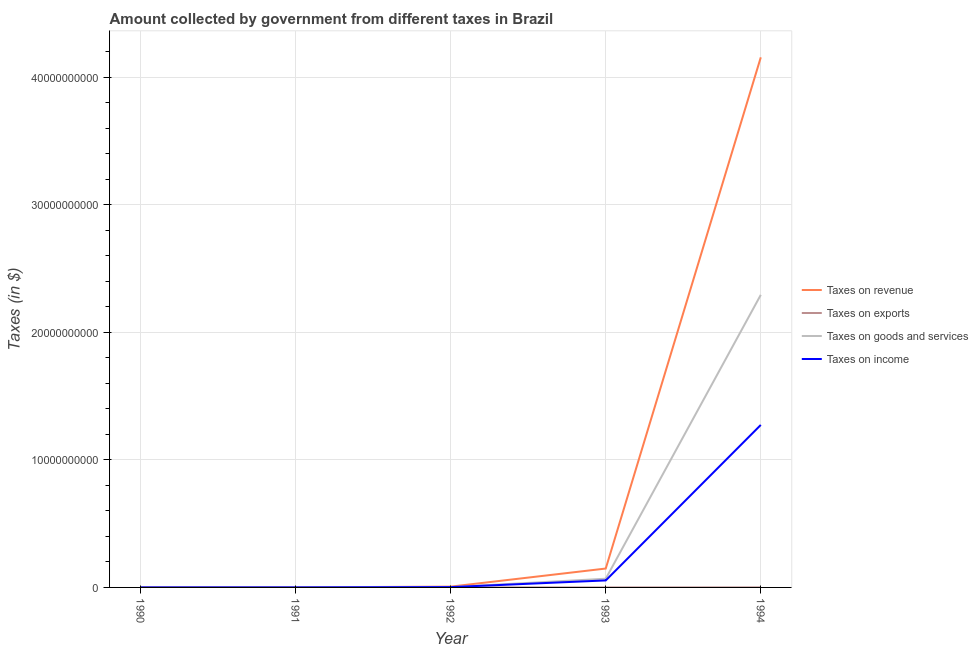How many different coloured lines are there?
Ensure brevity in your answer.  4. Does the line corresponding to amount collected as tax on goods intersect with the line corresponding to amount collected as tax on revenue?
Offer a very short reply. No. Is the number of lines equal to the number of legend labels?
Give a very brief answer. Yes. What is the amount collected as tax on income in 1994?
Provide a short and direct response. 1.27e+1. Across all years, what is the maximum amount collected as tax on goods?
Provide a short and direct response. 2.29e+1. Across all years, what is the minimum amount collected as tax on goods?
Make the answer very short. 6.37e+05. In which year was the amount collected as tax on revenue minimum?
Offer a terse response. 1990. What is the total amount collected as tax on goods in the graph?
Your answer should be compact. 2.36e+1. What is the difference between the amount collected as tax on goods in 1990 and that in 1991?
Provide a short and direct response. -2.03e+06. What is the difference between the amount collected as tax on goods in 1991 and the amount collected as tax on revenue in 1994?
Your answer should be very brief. -4.15e+1. What is the average amount collected as tax on goods per year?
Your answer should be compact. 4.73e+09. In the year 1994, what is the difference between the amount collected as tax on income and amount collected as tax on revenue?
Offer a very short reply. -2.88e+1. In how many years, is the amount collected as tax on income greater than 40000000000 $?
Give a very brief answer. 0. What is the ratio of the amount collected as tax on exports in 1990 to that in 1994?
Offer a very short reply. 0. Is the amount collected as tax on goods in 1990 less than that in 1991?
Give a very brief answer. Yes. Is the difference between the amount collected as tax on revenue in 1992 and 1994 greater than the difference between the amount collected as tax on exports in 1992 and 1994?
Provide a succinct answer. No. What is the difference between the highest and the second highest amount collected as tax on income?
Make the answer very short. 1.22e+1. What is the difference between the highest and the lowest amount collected as tax on revenue?
Offer a very short reply. 4.15e+1. In how many years, is the amount collected as tax on income greater than the average amount collected as tax on income taken over all years?
Ensure brevity in your answer.  1. Is the sum of the amount collected as tax on exports in 1992 and 1994 greater than the maximum amount collected as tax on revenue across all years?
Keep it short and to the point. No. Is it the case that in every year, the sum of the amount collected as tax on income and amount collected as tax on revenue is greater than the sum of amount collected as tax on goods and amount collected as tax on exports?
Provide a succinct answer. No. Does the amount collected as tax on goods monotonically increase over the years?
Offer a terse response. Yes. Is the amount collected as tax on exports strictly greater than the amount collected as tax on income over the years?
Your response must be concise. No. How many years are there in the graph?
Offer a terse response. 5. Are the values on the major ticks of Y-axis written in scientific E-notation?
Give a very brief answer. No. Does the graph contain grids?
Offer a terse response. Yes. What is the title of the graph?
Offer a terse response. Amount collected by government from different taxes in Brazil. Does "Permission" appear as one of the legend labels in the graph?
Offer a terse response. No. What is the label or title of the Y-axis?
Ensure brevity in your answer.  Taxes (in $). What is the Taxes (in $) of Taxes on revenue in 1990?
Give a very brief answer. 1.39e+06. What is the Taxes (in $) in Taxes on exports in 1990?
Provide a succinct answer. 1018.18. What is the Taxes (in $) in Taxes on goods and services in 1990?
Offer a very short reply. 6.37e+05. What is the Taxes (in $) in Taxes on income in 1990?
Make the answer very short. 5.39e+05. What is the Taxes (in $) of Taxes on revenue in 1991?
Offer a terse response. 5.75e+06. What is the Taxes (in $) in Taxes on exports in 1991?
Offer a terse response. 1527.27. What is the Taxes (in $) of Taxes on goods and services in 1991?
Your answer should be compact. 2.67e+06. What is the Taxes (in $) in Taxes on income in 1991?
Ensure brevity in your answer.  2.15e+06. What is the Taxes (in $) of Taxes on revenue in 1992?
Your response must be concise. 6.24e+07. What is the Taxes (in $) of Taxes on exports in 1992?
Keep it short and to the point. 1200. What is the Taxes (in $) in Taxes on goods and services in 1992?
Provide a succinct answer. 2.66e+07. What is the Taxes (in $) of Taxes on income in 1992?
Your answer should be very brief. 2.49e+07. What is the Taxes (in $) of Taxes on revenue in 1993?
Your response must be concise. 1.48e+09. What is the Taxes (in $) in Taxes on goods and services in 1993?
Keep it short and to the point. 6.82e+08. What is the Taxes (in $) of Taxes on income in 1993?
Offer a very short reply. 5.48e+08. What is the Taxes (in $) of Taxes on revenue in 1994?
Provide a short and direct response. 4.15e+1. What is the Taxes (in $) of Taxes on exports in 1994?
Your answer should be very brief. 2.90e+06. What is the Taxes (in $) in Taxes on goods and services in 1994?
Keep it short and to the point. 2.29e+1. What is the Taxes (in $) of Taxes on income in 1994?
Your response must be concise. 1.27e+1. Across all years, what is the maximum Taxes (in $) of Taxes on revenue?
Your answer should be very brief. 4.15e+1. Across all years, what is the maximum Taxes (in $) in Taxes on exports?
Your response must be concise. 2.90e+06. Across all years, what is the maximum Taxes (in $) of Taxes on goods and services?
Keep it short and to the point. 2.29e+1. Across all years, what is the maximum Taxes (in $) of Taxes on income?
Your answer should be compact. 1.27e+1. Across all years, what is the minimum Taxes (in $) of Taxes on revenue?
Offer a terse response. 1.39e+06. Across all years, what is the minimum Taxes (in $) of Taxes on exports?
Keep it short and to the point. 1018.18. Across all years, what is the minimum Taxes (in $) in Taxes on goods and services?
Offer a very short reply. 6.37e+05. Across all years, what is the minimum Taxes (in $) in Taxes on income?
Make the answer very short. 5.39e+05. What is the total Taxes (in $) of Taxes on revenue in the graph?
Offer a very short reply. 4.31e+1. What is the total Taxes (in $) of Taxes on exports in the graph?
Your response must be concise. 3.30e+06. What is the total Taxes (in $) in Taxes on goods and services in the graph?
Offer a very short reply. 2.36e+1. What is the total Taxes (in $) of Taxes on income in the graph?
Ensure brevity in your answer.  1.33e+1. What is the difference between the Taxes (in $) of Taxes on revenue in 1990 and that in 1991?
Give a very brief answer. -4.36e+06. What is the difference between the Taxes (in $) in Taxes on exports in 1990 and that in 1991?
Ensure brevity in your answer.  -509.09. What is the difference between the Taxes (in $) in Taxes on goods and services in 1990 and that in 1991?
Make the answer very short. -2.03e+06. What is the difference between the Taxes (in $) of Taxes on income in 1990 and that in 1991?
Provide a succinct answer. -1.61e+06. What is the difference between the Taxes (in $) in Taxes on revenue in 1990 and that in 1992?
Ensure brevity in your answer.  -6.10e+07. What is the difference between the Taxes (in $) of Taxes on exports in 1990 and that in 1992?
Ensure brevity in your answer.  -181.82. What is the difference between the Taxes (in $) in Taxes on goods and services in 1990 and that in 1992?
Your answer should be compact. -2.59e+07. What is the difference between the Taxes (in $) in Taxes on income in 1990 and that in 1992?
Keep it short and to the point. -2.44e+07. What is the difference between the Taxes (in $) in Taxes on revenue in 1990 and that in 1993?
Keep it short and to the point. -1.48e+09. What is the difference between the Taxes (in $) of Taxes on exports in 1990 and that in 1993?
Offer a terse response. -3.99e+05. What is the difference between the Taxes (in $) in Taxes on goods and services in 1990 and that in 1993?
Keep it short and to the point. -6.82e+08. What is the difference between the Taxes (in $) of Taxes on income in 1990 and that in 1993?
Make the answer very short. -5.48e+08. What is the difference between the Taxes (in $) in Taxes on revenue in 1990 and that in 1994?
Your answer should be compact. -4.15e+1. What is the difference between the Taxes (in $) in Taxes on exports in 1990 and that in 1994?
Make the answer very short. -2.90e+06. What is the difference between the Taxes (in $) of Taxes on goods and services in 1990 and that in 1994?
Make the answer very short. -2.29e+1. What is the difference between the Taxes (in $) in Taxes on income in 1990 and that in 1994?
Provide a short and direct response. -1.27e+1. What is the difference between the Taxes (in $) in Taxes on revenue in 1991 and that in 1992?
Make the answer very short. -5.66e+07. What is the difference between the Taxes (in $) in Taxes on exports in 1991 and that in 1992?
Make the answer very short. 327.27. What is the difference between the Taxes (in $) of Taxes on goods and services in 1991 and that in 1992?
Keep it short and to the point. -2.39e+07. What is the difference between the Taxes (in $) of Taxes on income in 1991 and that in 1992?
Offer a terse response. -2.28e+07. What is the difference between the Taxes (in $) in Taxes on revenue in 1991 and that in 1993?
Your answer should be compact. -1.47e+09. What is the difference between the Taxes (in $) in Taxes on exports in 1991 and that in 1993?
Keep it short and to the point. -3.98e+05. What is the difference between the Taxes (in $) of Taxes on goods and services in 1991 and that in 1993?
Make the answer very short. -6.80e+08. What is the difference between the Taxes (in $) of Taxes on income in 1991 and that in 1993?
Make the answer very short. -5.46e+08. What is the difference between the Taxes (in $) in Taxes on revenue in 1991 and that in 1994?
Ensure brevity in your answer.  -4.15e+1. What is the difference between the Taxes (in $) in Taxes on exports in 1991 and that in 1994?
Give a very brief answer. -2.90e+06. What is the difference between the Taxes (in $) in Taxes on goods and services in 1991 and that in 1994?
Provide a short and direct response. -2.29e+1. What is the difference between the Taxes (in $) of Taxes on income in 1991 and that in 1994?
Provide a succinct answer. -1.27e+1. What is the difference between the Taxes (in $) of Taxes on revenue in 1992 and that in 1993?
Your answer should be very brief. -1.42e+09. What is the difference between the Taxes (in $) in Taxes on exports in 1992 and that in 1993?
Offer a terse response. -3.99e+05. What is the difference between the Taxes (in $) of Taxes on goods and services in 1992 and that in 1993?
Offer a terse response. -6.56e+08. What is the difference between the Taxes (in $) in Taxes on income in 1992 and that in 1993?
Provide a succinct answer. -5.24e+08. What is the difference between the Taxes (in $) in Taxes on revenue in 1992 and that in 1994?
Your answer should be compact. -4.15e+1. What is the difference between the Taxes (in $) of Taxes on exports in 1992 and that in 1994?
Make the answer very short. -2.90e+06. What is the difference between the Taxes (in $) in Taxes on goods and services in 1992 and that in 1994?
Your response must be concise. -2.29e+1. What is the difference between the Taxes (in $) in Taxes on income in 1992 and that in 1994?
Your response must be concise. -1.27e+1. What is the difference between the Taxes (in $) of Taxes on revenue in 1993 and that in 1994?
Offer a terse response. -4.01e+1. What is the difference between the Taxes (in $) of Taxes on exports in 1993 and that in 1994?
Make the answer very short. -2.50e+06. What is the difference between the Taxes (in $) of Taxes on goods and services in 1993 and that in 1994?
Your response must be concise. -2.22e+1. What is the difference between the Taxes (in $) of Taxes on income in 1993 and that in 1994?
Provide a short and direct response. -1.22e+1. What is the difference between the Taxes (in $) in Taxes on revenue in 1990 and the Taxes (in $) in Taxes on exports in 1991?
Provide a succinct answer. 1.39e+06. What is the difference between the Taxes (in $) of Taxes on revenue in 1990 and the Taxes (in $) of Taxes on goods and services in 1991?
Offer a terse response. -1.28e+06. What is the difference between the Taxes (in $) of Taxes on revenue in 1990 and the Taxes (in $) of Taxes on income in 1991?
Offer a terse response. -7.63e+05. What is the difference between the Taxes (in $) of Taxes on exports in 1990 and the Taxes (in $) of Taxes on goods and services in 1991?
Ensure brevity in your answer.  -2.67e+06. What is the difference between the Taxes (in $) of Taxes on exports in 1990 and the Taxes (in $) of Taxes on income in 1991?
Your answer should be very brief. -2.15e+06. What is the difference between the Taxes (in $) in Taxes on goods and services in 1990 and the Taxes (in $) in Taxes on income in 1991?
Your answer should be compact. -1.51e+06. What is the difference between the Taxes (in $) of Taxes on revenue in 1990 and the Taxes (in $) of Taxes on exports in 1992?
Keep it short and to the point. 1.39e+06. What is the difference between the Taxes (in $) in Taxes on revenue in 1990 and the Taxes (in $) in Taxes on goods and services in 1992?
Offer a terse response. -2.52e+07. What is the difference between the Taxes (in $) in Taxes on revenue in 1990 and the Taxes (in $) in Taxes on income in 1992?
Your answer should be very brief. -2.35e+07. What is the difference between the Taxes (in $) in Taxes on exports in 1990 and the Taxes (in $) in Taxes on goods and services in 1992?
Ensure brevity in your answer.  -2.66e+07. What is the difference between the Taxes (in $) in Taxes on exports in 1990 and the Taxes (in $) in Taxes on income in 1992?
Offer a very short reply. -2.49e+07. What is the difference between the Taxes (in $) in Taxes on goods and services in 1990 and the Taxes (in $) in Taxes on income in 1992?
Make the answer very short. -2.43e+07. What is the difference between the Taxes (in $) of Taxes on revenue in 1990 and the Taxes (in $) of Taxes on exports in 1993?
Your response must be concise. 9.87e+05. What is the difference between the Taxes (in $) in Taxes on revenue in 1990 and the Taxes (in $) in Taxes on goods and services in 1993?
Provide a short and direct response. -6.81e+08. What is the difference between the Taxes (in $) of Taxes on revenue in 1990 and the Taxes (in $) of Taxes on income in 1993?
Provide a succinct answer. -5.47e+08. What is the difference between the Taxes (in $) in Taxes on exports in 1990 and the Taxes (in $) in Taxes on goods and services in 1993?
Your answer should be very brief. -6.82e+08. What is the difference between the Taxes (in $) of Taxes on exports in 1990 and the Taxes (in $) of Taxes on income in 1993?
Make the answer very short. -5.48e+08. What is the difference between the Taxes (in $) in Taxes on goods and services in 1990 and the Taxes (in $) in Taxes on income in 1993?
Offer a very short reply. -5.48e+08. What is the difference between the Taxes (in $) in Taxes on revenue in 1990 and the Taxes (in $) in Taxes on exports in 1994?
Provide a short and direct response. -1.51e+06. What is the difference between the Taxes (in $) of Taxes on revenue in 1990 and the Taxes (in $) of Taxes on goods and services in 1994?
Make the answer very short. -2.29e+1. What is the difference between the Taxes (in $) of Taxes on revenue in 1990 and the Taxes (in $) of Taxes on income in 1994?
Your response must be concise. -1.27e+1. What is the difference between the Taxes (in $) of Taxes on exports in 1990 and the Taxes (in $) of Taxes on goods and services in 1994?
Give a very brief answer. -2.29e+1. What is the difference between the Taxes (in $) in Taxes on exports in 1990 and the Taxes (in $) in Taxes on income in 1994?
Your answer should be compact. -1.27e+1. What is the difference between the Taxes (in $) of Taxes on goods and services in 1990 and the Taxes (in $) of Taxes on income in 1994?
Offer a very short reply. -1.27e+1. What is the difference between the Taxes (in $) of Taxes on revenue in 1991 and the Taxes (in $) of Taxes on exports in 1992?
Your answer should be very brief. 5.74e+06. What is the difference between the Taxes (in $) of Taxes on revenue in 1991 and the Taxes (in $) of Taxes on goods and services in 1992?
Your answer should be very brief. -2.08e+07. What is the difference between the Taxes (in $) in Taxes on revenue in 1991 and the Taxes (in $) in Taxes on income in 1992?
Offer a terse response. -1.92e+07. What is the difference between the Taxes (in $) in Taxes on exports in 1991 and the Taxes (in $) in Taxes on goods and services in 1992?
Provide a succinct answer. -2.66e+07. What is the difference between the Taxes (in $) of Taxes on exports in 1991 and the Taxes (in $) of Taxes on income in 1992?
Provide a short and direct response. -2.49e+07. What is the difference between the Taxes (in $) in Taxes on goods and services in 1991 and the Taxes (in $) in Taxes on income in 1992?
Your answer should be very brief. -2.22e+07. What is the difference between the Taxes (in $) in Taxes on revenue in 1991 and the Taxes (in $) in Taxes on exports in 1993?
Ensure brevity in your answer.  5.35e+06. What is the difference between the Taxes (in $) of Taxes on revenue in 1991 and the Taxes (in $) of Taxes on goods and services in 1993?
Your answer should be compact. -6.76e+08. What is the difference between the Taxes (in $) in Taxes on revenue in 1991 and the Taxes (in $) in Taxes on income in 1993?
Make the answer very short. -5.43e+08. What is the difference between the Taxes (in $) of Taxes on exports in 1991 and the Taxes (in $) of Taxes on goods and services in 1993?
Keep it short and to the point. -6.82e+08. What is the difference between the Taxes (in $) in Taxes on exports in 1991 and the Taxes (in $) in Taxes on income in 1993?
Keep it short and to the point. -5.48e+08. What is the difference between the Taxes (in $) in Taxes on goods and services in 1991 and the Taxes (in $) in Taxes on income in 1993?
Your response must be concise. -5.46e+08. What is the difference between the Taxes (in $) in Taxes on revenue in 1991 and the Taxes (in $) in Taxes on exports in 1994?
Provide a succinct answer. 2.85e+06. What is the difference between the Taxes (in $) of Taxes on revenue in 1991 and the Taxes (in $) of Taxes on goods and services in 1994?
Your answer should be very brief. -2.29e+1. What is the difference between the Taxes (in $) in Taxes on revenue in 1991 and the Taxes (in $) in Taxes on income in 1994?
Your response must be concise. -1.27e+1. What is the difference between the Taxes (in $) of Taxes on exports in 1991 and the Taxes (in $) of Taxes on goods and services in 1994?
Keep it short and to the point. -2.29e+1. What is the difference between the Taxes (in $) in Taxes on exports in 1991 and the Taxes (in $) in Taxes on income in 1994?
Offer a very short reply. -1.27e+1. What is the difference between the Taxes (in $) of Taxes on goods and services in 1991 and the Taxes (in $) of Taxes on income in 1994?
Your answer should be very brief. -1.27e+1. What is the difference between the Taxes (in $) of Taxes on revenue in 1992 and the Taxes (in $) of Taxes on exports in 1993?
Provide a succinct answer. 6.20e+07. What is the difference between the Taxes (in $) of Taxes on revenue in 1992 and the Taxes (in $) of Taxes on goods and services in 1993?
Give a very brief answer. -6.20e+08. What is the difference between the Taxes (in $) of Taxes on revenue in 1992 and the Taxes (in $) of Taxes on income in 1993?
Ensure brevity in your answer.  -4.86e+08. What is the difference between the Taxes (in $) in Taxes on exports in 1992 and the Taxes (in $) in Taxes on goods and services in 1993?
Provide a succinct answer. -6.82e+08. What is the difference between the Taxes (in $) of Taxes on exports in 1992 and the Taxes (in $) of Taxes on income in 1993?
Ensure brevity in your answer.  -5.48e+08. What is the difference between the Taxes (in $) of Taxes on goods and services in 1992 and the Taxes (in $) of Taxes on income in 1993?
Make the answer very short. -5.22e+08. What is the difference between the Taxes (in $) in Taxes on revenue in 1992 and the Taxes (in $) in Taxes on exports in 1994?
Give a very brief answer. 5.95e+07. What is the difference between the Taxes (in $) in Taxes on revenue in 1992 and the Taxes (in $) in Taxes on goods and services in 1994?
Your response must be concise. -2.29e+1. What is the difference between the Taxes (in $) of Taxes on revenue in 1992 and the Taxes (in $) of Taxes on income in 1994?
Provide a succinct answer. -1.27e+1. What is the difference between the Taxes (in $) of Taxes on exports in 1992 and the Taxes (in $) of Taxes on goods and services in 1994?
Make the answer very short. -2.29e+1. What is the difference between the Taxes (in $) in Taxes on exports in 1992 and the Taxes (in $) in Taxes on income in 1994?
Offer a terse response. -1.27e+1. What is the difference between the Taxes (in $) of Taxes on goods and services in 1992 and the Taxes (in $) of Taxes on income in 1994?
Your answer should be compact. -1.27e+1. What is the difference between the Taxes (in $) of Taxes on revenue in 1993 and the Taxes (in $) of Taxes on exports in 1994?
Your response must be concise. 1.48e+09. What is the difference between the Taxes (in $) of Taxes on revenue in 1993 and the Taxes (in $) of Taxes on goods and services in 1994?
Your answer should be compact. -2.14e+1. What is the difference between the Taxes (in $) of Taxes on revenue in 1993 and the Taxes (in $) of Taxes on income in 1994?
Make the answer very short. -1.13e+1. What is the difference between the Taxes (in $) in Taxes on exports in 1993 and the Taxes (in $) in Taxes on goods and services in 1994?
Offer a very short reply. -2.29e+1. What is the difference between the Taxes (in $) in Taxes on exports in 1993 and the Taxes (in $) in Taxes on income in 1994?
Your response must be concise. -1.27e+1. What is the difference between the Taxes (in $) of Taxes on goods and services in 1993 and the Taxes (in $) of Taxes on income in 1994?
Offer a very short reply. -1.21e+1. What is the average Taxes (in $) of Taxes on revenue per year?
Make the answer very short. 8.62e+09. What is the average Taxes (in $) in Taxes on exports per year?
Provide a short and direct response. 6.61e+05. What is the average Taxes (in $) in Taxes on goods and services per year?
Offer a terse response. 4.73e+09. What is the average Taxes (in $) of Taxes on income per year?
Your answer should be very brief. 2.66e+09. In the year 1990, what is the difference between the Taxes (in $) in Taxes on revenue and Taxes (in $) in Taxes on exports?
Give a very brief answer. 1.39e+06. In the year 1990, what is the difference between the Taxes (in $) of Taxes on revenue and Taxes (in $) of Taxes on goods and services?
Provide a short and direct response. 7.50e+05. In the year 1990, what is the difference between the Taxes (in $) of Taxes on revenue and Taxes (in $) of Taxes on income?
Ensure brevity in your answer.  8.48e+05. In the year 1990, what is the difference between the Taxes (in $) in Taxes on exports and Taxes (in $) in Taxes on goods and services?
Provide a short and direct response. -6.36e+05. In the year 1990, what is the difference between the Taxes (in $) in Taxes on exports and Taxes (in $) in Taxes on income?
Keep it short and to the point. -5.38e+05. In the year 1990, what is the difference between the Taxes (in $) of Taxes on goods and services and Taxes (in $) of Taxes on income?
Your answer should be very brief. 9.83e+04. In the year 1991, what is the difference between the Taxes (in $) of Taxes on revenue and Taxes (in $) of Taxes on exports?
Your answer should be very brief. 5.74e+06. In the year 1991, what is the difference between the Taxes (in $) of Taxes on revenue and Taxes (in $) of Taxes on goods and services?
Provide a succinct answer. 3.07e+06. In the year 1991, what is the difference between the Taxes (in $) of Taxes on revenue and Taxes (in $) of Taxes on income?
Give a very brief answer. 3.60e+06. In the year 1991, what is the difference between the Taxes (in $) of Taxes on exports and Taxes (in $) of Taxes on goods and services?
Ensure brevity in your answer.  -2.67e+06. In the year 1991, what is the difference between the Taxes (in $) of Taxes on exports and Taxes (in $) of Taxes on income?
Give a very brief answer. -2.15e+06. In the year 1991, what is the difference between the Taxes (in $) of Taxes on goods and services and Taxes (in $) of Taxes on income?
Ensure brevity in your answer.  5.20e+05. In the year 1992, what is the difference between the Taxes (in $) in Taxes on revenue and Taxes (in $) in Taxes on exports?
Offer a very short reply. 6.24e+07. In the year 1992, what is the difference between the Taxes (in $) in Taxes on revenue and Taxes (in $) in Taxes on goods and services?
Provide a succinct answer. 3.58e+07. In the year 1992, what is the difference between the Taxes (in $) of Taxes on revenue and Taxes (in $) of Taxes on income?
Ensure brevity in your answer.  3.75e+07. In the year 1992, what is the difference between the Taxes (in $) of Taxes on exports and Taxes (in $) of Taxes on goods and services?
Your response must be concise. -2.66e+07. In the year 1992, what is the difference between the Taxes (in $) in Taxes on exports and Taxes (in $) in Taxes on income?
Ensure brevity in your answer.  -2.49e+07. In the year 1992, what is the difference between the Taxes (in $) in Taxes on goods and services and Taxes (in $) in Taxes on income?
Your answer should be very brief. 1.67e+06. In the year 1993, what is the difference between the Taxes (in $) in Taxes on revenue and Taxes (in $) in Taxes on exports?
Your answer should be compact. 1.48e+09. In the year 1993, what is the difference between the Taxes (in $) of Taxes on revenue and Taxes (in $) of Taxes on goods and services?
Ensure brevity in your answer.  7.98e+08. In the year 1993, what is the difference between the Taxes (in $) of Taxes on revenue and Taxes (in $) of Taxes on income?
Keep it short and to the point. 9.32e+08. In the year 1993, what is the difference between the Taxes (in $) in Taxes on exports and Taxes (in $) in Taxes on goods and services?
Ensure brevity in your answer.  -6.82e+08. In the year 1993, what is the difference between the Taxes (in $) of Taxes on exports and Taxes (in $) of Taxes on income?
Provide a succinct answer. -5.48e+08. In the year 1993, what is the difference between the Taxes (in $) of Taxes on goods and services and Taxes (in $) of Taxes on income?
Your answer should be compact. 1.34e+08. In the year 1994, what is the difference between the Taxes (in $) in Taxes on revenue and Taxes (in $) in Taxes on exports?
Make the answer very short. 4.15e+1. In the year 1994, what is the difference between the Taxes (in $) of Taxes on revenue and Taxes (in $) of Taxes on goods and services?
Ensure brevity in your answer.  1.86e+1. In the year 1994, what is the difference between the Taxes (in $) in Taxes on revenue and Taxes (in $) in Taxes on income?
Your answer should be compact. 2.88e+1. In the year 1994, what is the difference between the Taxes (in $) in Taxes on exports and Taxes (in $) in Taxes on goods and services?
Ensure brevity in your answer.  -2.29e+1. In the year 1994, what is the difference between the Taxes (in $) in Taxes on exports and Taxes (in $) in Taxes on income?
Make the answer very short. -1.27e+1. In the year 1994, what is the difference between the Taxes (in $) in Taxes on goods and services and Taxes (in $) in Taxes on income?
Provide a short and direct response. 1.02e+1. What is the ratio of the Taxes (in $) in Taxes on revenue in 1990 to that in 1991?
Your answer should be very brief. 0.24. What is the ratio of the Taxes (in $) of Taxes on goods and services in 1990 to that in 1991?
Provide a succinct answer. 0.24. What is the ratio of the Taxes (in $) of Taxes on income in 1990 to that in 1991?
Keep it short and to the point. 0.25. What is the ratio of the Taxes (in $) of Taxes on revenue in 1990 to that in 1992?
Provide a succinct answer. 0.02. What is the ratio of the Taxes (in $) of Taxes on exports in 1990 to that in 1992?
Your answer should be very brief. 0.85. What is the ratio of the Taxes (in $) in Taxes on goods and services in 1990 to that in 1992?
Make the answer very short. 0.02. What is the ratio of the Taxes (in $) in Taxes on income in 1990 to that in 1992?
Your answer should be compact. 0.02. What is the ratio of the Taxes (in $) of Taxes on revenue in 1990 to that in 1993?
Keep it short and to the point. 0. What is the ratio of the Taxes (in $) in Taxes on exports in 1990 to that in 1993?
Provide a short and direct response. 0. What is the ratio of the Taxes (in $) in Taxes on goods and services in 1990 to that in 1993?
Offer a terse response. 0. What is the ratio of the Taxes (in $) of Taxes on goods and services in 1990 to that in 1994?
Your answer should be compact. 0. What is the ratio of the Taxes (in $) of Taxes on income in 1990 to that in 1994?
Your answer should be compact. 0. What is the ratio of the Taxes (in $) in Taxes on revenue in 1991 to that in 1992?
Your response must be concise. 0.09. What is the ratio of the Taxes (in $) in Taxes on exports in 1991 to that in 1992?
Ensure brevity in your answer.  1.27. What is the ratio of the Taxes (in $) in Taxes on goods and services in 1991 to that in 1992?
Offer a terse response. 0.1. What is the ratio of the Taxes (in $) of Taxes on income in 1991 to that in 1992?
Keep it short and to the point. 0.09. What is the ratio of the Taxes (in $) in Taxes on revenue in 1991 to that in 1993?
Your response must be concise. 0. What is the ratio of the Taxes (in $) in Taxes on exports in 1991 to that in 1993?
Provide a short and direct response. 0. What is the ratio of the Taxes (in $) in Taxes on goods and services in 1991 to that in 1993?
Offer a terse response. 0. What is the ratio of the Taxes (in $) in Taxes on income in 1991 to that in 1993?
Offer a very short reply. 0. What is the ratio of the Taxes (in $) of Taxes on revenue in 1991 to that in 1994?
Offer a very short reply. 0. What is the ratio of the Taxes (in $) of Taxes on exports in 1991 to that in 1994?
Your answer should be compact. 0. What is the ratio of the Taxes (in $) of Taxes on goods and services in 1991 to that in 1994?
Keep it short and to the point. 0. What is the ratio of the Taxes (in $) in Taxes on revenue in 1992 to that in 1993?
Offer a very short reply. 0.04. What is the ratio of the Taxes (in $) in Taxes on exports in 1992 to that in 1993?
Your answer should be very brief. 0. What is the ratio of the Taxes (in $) in Taxes on goods and services in 1992 to that in 1993?
Provide a succinct answer. 0.04. What is the ratio of the Taxes (in $) in Taxes on income in 1992 to that in 1993?
Give a very brief answer. 0.05. What is the ratio of the Taxes (in $) in Taxes on revenue in 1992 to that in 1994?
Give a very brief answer. 0. What is the ratio of the Taxes (in $) of Taxes on goods and services in 1992 to that in 1994?
Your answer should be compact. 0. What is the ratio of the Taxes (in $) in Taxes on income in 1992 to that in 1994?
Your answer should be compact. 0. What is the ratio of the Taxes (in $) of Taxes on revenue in 1993 to that in 1994?
Provide a short and direct response. 0.04. What is the ratio of the Taxes (in $) of Taxes on exports in 1993 to that in 1994?
Offer a very short reply. 0.14. What is the ratio of the Taxes (in $) of Taxes on goods and services in 1993 to that in 1994?
Your answer should be compact. 0.03. What is the ratio of the Taxes (in $) of Taxes on income in 1993 to that in 1994?
Offer a very short reply. 0.04. What is the difference between the highest and the second highest Taxes (in $) of Taxes on revenue?
Your answer should be very brief. 4.01e+1. What is the difference between the highest and the second highest Taxes (in $) in Taxes on exports?
Offer a terse response. 2.50e+06. What is the difference between the highest and the second highest Taxes (in $) in Taxes on goods and services?
Your answer should be very brief. 2.22e+1. What is the difference between the highest and the second highest Taxes (in $) in Taxes on income?
Your response must be concise. 1.22e+1. What is the difference between the highest and the lowest Taxes (in $) of Taxes on revenue?
Offer a terse response. 4.15e+1. What is the difference between the highest and the lowest Taxes (in $) of Taxes on exports?
Your response must be concise. 2.90e+06. What is the difference between the highest and the lowest Taxes (in $) of Taxes on goods and services?
Your answer should be compact. 2.29e+1. What is the difference between the highest and the lowest Taxes (in $) of Taxes on income?
Ensure brevity in your answer.  1.27e+1. 